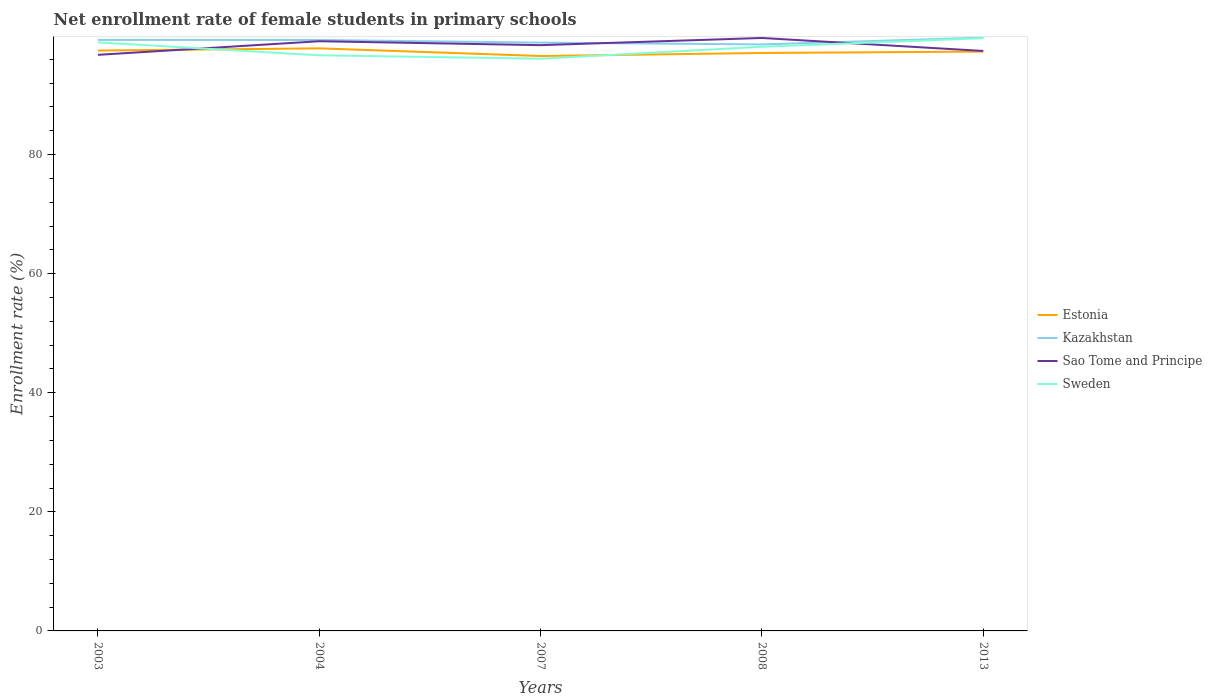Across all years, what is the maximum net enrollment rate of female students in primary schools in Sao Tome and Principe?
Ensure brevity in your answer.  96.75. In which year was the net enrollment rate of female students in primary schools in Sweden maximum?
Ensure brevity in your answer.  2007. What is the total net enrollment rate of female students in primary schools in Sao Tome and Principe in the graph?
Make the answer very short. -0.65. What is the difference between the highest and the second highest net enrollment rate of female students in primary schools in Estonia?
Your answer should be very brief. 1.29. What is the difference between the highest and the lowest net enrollment rate of female students in primary schools in Sao Tome and Principe?
Offer a very short reply. 3. How many lines are there?
Give a very brief answer. 4. Are the values on the major ticks of Y-axis written in scientific E-notation?
Your response must be concise. No. Does the graph contain any zero values?
Give a very brief answer. No. How are the legend labels stacked?
Offer a terse response. Vertical. What is the title of the graph?
Provide a succinct answer. Net enrollment rate of female students in primary schools. What is the label or title of the Y-axis?
Offer a terse response. Enrollment rate (%). What is the Enrollment rate (%) of Estonia in 2003?
Ensure brevity in your answer.  97.47. What is the Enrollment rate (%) of Kazakhstan in 2003?
Keep it short and to the point. 99.25. What is the Enrollment rate (%) in Sao Tome and Principe in 2003?
Your answer should be very brief. 96.75. What is the Enrollment rate (%) of Sweden in 2003?
Your answer should be very brief. 98.83. What is the Enrollment rate (%) in Estonia in 2004?
Provide a short and direct response. 97.83. What is the Enrollment rate (%) in Kazakhstan in 2004?
Make the answer very short. 99.24. What is the Enrollment rate (%) in Sao Tome and Principe in 2004?
Keep it short and to the point. 99.03. What is the Enrollment rate (%) in Sweden in 2004?
Keep it short and to the point. 96.67. What is the Enrollment rate (%) of Estonia in 2007?
Keep it short and to the point. 96.55. What is the Enrollment rate (%) in Kazakhstan in 2007?
Give a very brief answer. 98.8. What is the Enrollment rate (%) of Sao Tome and Principe in 2007?
Give a very brief answer. 98.37. What is the Enrollment rate (%) in Sweden in 2007?
Give a very brief answer. 96.1. What is the Enrollment rate (%) in Estonia in 2008?
Provide a succinct answer. 97.06. What is the Enrollment rate (%) of Kazakhstan in 2008?
Provide a succinct answer. 98.49. What is the Enrollment rate (%) of Sao Tome and Principe in 2008?
Provide a succinct answer. 99.58. What is the Enrollment rate (%) of Sweden in 2008?
Offer a terse response. 98.1. What is the Enrollment rate (%) of Estonia in 2013?
Provide a short and direct response. 97.29. What is the Enrollment rate (%) in Kazakhstan in 2013?
Keep it short and to the point. 99.64. What is the Enrollment rate (%) of Sao Tome and Principe in 2013?
Provide a short and direct response. 97.39. What is the Enrollment rate (%) in Sweden in 2013?
Your answer should be very brief. 99.54. Across all years, what is the maximum Enrollment rate (%) of Estonia?
Your response must be concise. 97.83. Across all years, what is the maximum Enrollment rate (%) in Kazakhstan?
Make the answer very short. 99.64. Across all years, what is the maximum Enrollment rate (%) in Sao Tome and Principe?
Give a very brief answer. 99.58. Across all years, what is the maximum Enrollment rate (%) of Sweden?
Offer a very short reply. 99.54. Across all years, what is the minimum Enrollment rate (%) of Estonia?
Offer a terse response. 96.55. Across all years, what is the minimum Enrollment rate (%) in Kazakhstan?
Your response must be concise. 98.49. Across all years, what is the minimum Enrollment rate (%) in Sao Tome and Principe?
Offer a very short reply. 96.75. Across all years, what is the minimum Enrollment rate (%) of Sweden?
Offer a very short reply. 96.1. What is the total Enrollment rate (%) of Estonia in the graph?
Your answer should be very brief. 486.2. What is the total Enrollment rate (%) of Kazakhstan in the graph?
Ensure brevity in your answer.  495.41. What is the total Enrollment rate (%) of Sao Tome and Principe in the graph?
Your answer should be compact. 491.12. What is the total Enrollment rate (%) in Sweden in the graph?
Keep it short and to the point. 489.24. What is the difference between the Enrollment rate (%) of Estonia in 2003 and that in 2004?
Your response must be concise. -0.37. What is the difference between the Enrollment rate (%) of Kazakhstan in 2003 and that in 2004?
Your answer should be compact. 0.01. What is the difference between the Enrollment rate (%) in Sao Tome and Principe in 2003 and that in 2004?
Keep it short and to the point. -2.28. What is the difference between the Enrollment rate (%) in Sweden in 2003 and that in 2004?
Your response must be concise. 2.16. What is the difference between the Enrollment rate (%) of Estonia in 2003 and that in 2007?
Offer a terse response. 0.92. What is the difference between the Enrollment rate (%) of Kazakhstan in 2003 and that in 2007?
Provide a succinct answer. 0.45. What is the difference between the Enrollment rate (%) in Sao Tome and Principe in 2003 and that in 2007?
Ensure brevity in your answer.  -1.62. What is the difference between the Enrollment rate (%) of Sweden in 2003 and that in 2007?
Provide a succinct answer. 2.73. What is the difference between the Enrollment rate (%) of Estonia in 2003 and that in 2008?
Offer a very short reply. 0.41. What is the difference between the Enrollment rate (%) of Kazakhstan in 2003 and that in 2008?
Keep it short and to the point. 0.76. What is the difference between the Enrollment rate (%) in Sao Tome and Principe in 2003 and that in 2008?
Your answer should be compact. -2.83. What is the difference between the Enrollment rate (%) of Sweden in 2003 and that in 2008?
Provide a short and direct response. 0.73. What is the difference between the Enrollment rate (%) of Estonia in 2003 and that in 2013?
Your answer should be very brief. 0.18. What is the difference between the Enrollment rate (%) in Kazakhstan in 2003 and that in 2013?
Your answer should be very brief. -0.39. What is the difference between the Enrollment rate (%) in Sao Tome and Principe in 2003 and that in 2013?
Give a very brief answer. -0.65. What is the difference between the Enrollment rate (%) in Sweden in 2003 and that in 2013?
Keep it short and to the point. -0.71. What is the difference between the Enrollment rate (%) of Estonia in 2004 and that in 2007?
Offer a terse response. 1.29. What is the difference between the Enrollment rate (%) of Kazakhstan in 2004 and that in 2007?
Offer a very short reply. 0.44. What is the difference between the Enrollment rate (%) in Sao Tome and Principe in 2004 and that in 2007?
Make the answer very short. 0.66. What is the difference between the Enrollment rate (%) of Sweden in 2004 and that in 2007?
Give a very brief answer. 0.57. What is the difference between the Enrollment rate (%) of Estonia in 2004 and that in 2008?
Your response must be concise. 0.77. What is the difference between the Enrollment rate (%) of Kazakhstan in 2004 and that in 2008?
Your answer should be compact. 0.74. What is the difference between the Enrollment rate (%) of Sao Tome and Principe in 2004 and that in 2008?
Make the answer very short. -0.55. What is the difference between the Enrollment rate (%) of Sweden in 2004 and that in 2008?
Ensure brevity in your answer.  -1.44. What is the difference between the Enrollment rate (%) in Estonia in 2004 and that in 2013?
Keep it short and to the point. 0.54. What is the difference between the Enrollment rate (%) in Kazakhstan in 2004 and that in 2013?
Give a very brief answer. -0.4. What is the difference between the Enrollment rate (%) in Sao Tome and Principe in 2004 and that in 2013?
Your answer should be very brief. 1.63. What is the difference between the Enrollment rate (%) of Sweden in 2004 and that in 2013?
Offer a very short reply. -2.87. What is the difference between the Enrollment rate (%) of Estonia in 2007 and that in 2008?
Offer a terse response. -0.51. What is the difference between the Enrollment rate (%) in Kazakhstan in 2007 and that in 2008?
Provide a succinct answer. 0.3. What is the difference between the Enrollment rate (%) in Sao Tome and Principe in 2007 and that in 2008?
Offer a terse response. -1.21. What is the difference between the Enrollment rate (%) in Sweden in 2007 and that in 2008?
Make the answer very short. -2.01. What is the difference between the Enrollment rate (%) of Estonia in 2007 and that in 2013?
Your response must be concise. -0.74. What is the difference between the Enrollment rate (%) in Kazakhstan in 2007 and that in 2013?
Keep it short and to the point. -0.84. What is the difference between the Enrollment rate (%) of Sao Tome and Principe in 2007 and that in 2013?
Ensure brevity in your answer.  0.98. What is the difference between the Enrollment rate (%) in Sweden in 2007 and that in 2013?
Keep it short and to the point. -3.44. What is the difference between the Enrollment rate (%) in Estonia in 2008 and that in 2013?
Provide a short and direct response. -0.23. What is the difference between the Enrollment rate (%) in Kazakhstan in 2008 and that in 2013?
Your answer should be very brief. -1.14. What is the difference between the Enrollment rate (%) in Sao Tome and Principe in 2008 and that in 2013?
Your answer should be very brief. 2.18. What is the difference between the Enrollment rate (%) of Sweden in 2008 and that in 2013?
Give a very brief answer. -1.43. What is the difference between the Enrollment rate (%) of Estonia in 2003 and the Enrollment rate (%) of Kazakhstan in 2004?
Give a very brief answer. -1.77. What is the difference between the Enrollment rate (%) in Estonia in 2003 and the Enrollment rate (%) in Sao Tome and Principe in 2004?
Provide a short and direct response. -1.56. What is the difference between the Enrollment rate (%) of Estonia in 2003 and the Enrollment rate (%) of Sweden in 2004?
Provide a succinct answer. 0.8. What is the difference between the Enrollment rate (%) in Kazakhstan in 2003 and the Enrollment rate (%) in Sao Tome and Principe in 2004?
Ensure brevity in your answer.  0.22. What is the difference between the Enrollment rate (%) of Kazakhstan in 2003 and the Enrollment rate (%) of Sweden in 2004?
Your response must be concise. 2.58. What is the difference between the Enrollment rate (%) of Sao Tome and Principe in 2003 and the Enrollment rate (%) of Sweden in 2004?
Your answer should be compact. 0.08. What is the difference between the Enrollment rate (%) of Estonia in 2003 and the Enrollment rate (%) of Kazakhstan in 2007?
Offer a terse response. -1.33. What is the difference between the Enrollment rate (%) of Estonia in 2003 and the Enrollment rate (%) of Sao Tome and Principe in 2007?
Your answer should be compact. -0.9. What is the difference between the Enrollment rate (%) of Estonia in 2003 and the Enrollment rate (%) of Sweden in 2007?
Offer a terse response. 1.37. What is the difference between the Enrollment rate (%) in Kazakhstan in 2003 and the Enrollment rate (%) in Sao Tome and Principe in 2007?
Your answer should be very brief. 0.88. What is the difference between the Enrollment rate (%) in Kazakhstan in 2003 and the Enrollment rate (%) in Sweden in 2007?
Provide a short and direct response. 3.15. What is the difference between the Enrollment rate (%) of Sao Tome and Principe in 2003 and the Enrollment rate (%) of Sweden in 2007?
Your answer should be very brief. 0.65. What is the difference between the Enrollment rate (%) in Estonia in 2003 and the Enrollment rate (%) in Kazakhstan in 2008?
Provide a succinct answer. -1.03. What is the difference between the Enrollment rate (%) in Estonia in 2003 and the Enrollment rate (%) in Sao Tome and Principe in 2008?
Provide a succinct answer. -2.11. What is the difference between the Enrollment rate (%) of Estonia in 2003 and the Enrollment rate (%) of Sweden in 2008?
Make the answer very short. -0.64. What is the difference between the Enrollment rate (%) of Kazakhstan in 2003 and the Enrollment rate (%) of Sao Tome and Principe in 2008?
Provide a short and direct response. -0.33. What is the difference between the Enrollment rate (%) of Kazakhstan in 2003 and the Enrollment rate (%) of Sweden in 2008?
Offer a terse response. 1.15. What is the difference between the Enrollment rate (%) of Sao Tome and Principe in 2003 and the Enrollment rate (%) of Sweden in 2008?
Offer a terse response. -1.36. What is the difference between the Enrollment rate (%) of Estonia in 2003 and the Enrollment rate (%) of Kazakhstan in 2013?
Provide a short and direct response. -2.17. What is the difference between the Enrollment rate (%) of Estonia in 2003 and the Enrollment rate (%) of Sao Tome and Principe in 2013?
Give a very brief answer. 0.07. What is the difference between the Enrollment rate (%) in Estonia in 2003 and the Enrollment rate (%) in Sweden in 2013?
Your answer should be compact. -2.07. What is the difference between the Enrollment rate (%) of Kazakhstan in 2003 and the Enrollment rate (%) of Sao Tome and Principe in 2013?
Offer a very short reply. 1.85. What is the difference between the Enrollment rate (%) in Kazakhstan in 2003 and the Enrollment rate (%) in Sweden in 2013?
Give a very brief answer. -0.29. What is the difference between the Enrollment rate (%) in Sao Tome and Principe in 2003 and the Enrollment rate (%) in Sweden in 2013?
Provide a short and direct response. -2.79. What is the difference between the Enrollment rate (%) in Estonia in 2004 and the Enrollment rate (%) in Kazakhstan in 2007?
Give a very brief answer. -0.96. What is the difference between the Enrollment rate (%) of Estonia in 2004 and the Enrollment rate (%) of Sao Tome and Principe in 2007?
Your answer should be very brief. -0.54. What is the difference between the Enrollment rate (%) in Estonia in 2004 and the Enrollment rate (%) in Sweden in 2007?
Make the answer very short. 1.74. What is the difference between the Enrollment rate (%) in Kazakhstan in 2004 and the Enrollment rate (%) in Sao Tome and Principe in 2007?
Provide a short and direct response. 0.87. What is the difference between the Enrollment rate (%) in Kazakhstan in 2004 and the Enrollment rate (%) in Sweden in 2007?
Your response must be concise. 3.14. What is the difference between the Enrollment rate (%) of Sao Tome and Principe in 2004 and the Enrollment rate (%) of Sweden in 2007?
Your answer should be very brief. 2.93. What is the difference between the Enrollment rate (%) in Estonia in 2004 and the Enrollment rate (%) in Kazakhstan in 2008?
Offer a terse response. -0.66. What is the difference between the Enrollment rate (%) of Estonia in 2004 and the Enrollment rate (%) of Sao Tome and Principe in 2008?
Provide a succinct answer. -1.74. What is the difference between the Enrollment rate (%) in Estonia in 2004 and the Enrollment rate (%) in Sweden in 2008?
Make the answer very short. -0.27. What is the difference between the Enrollment rate (%) of Kazakhstan in 2004 and the Enrollment rate (%) of Sao Tome and Principe in 2008?
Make the answer very short. -0.34. What is the difference between the Enrollment rate (%) of Kazakhstan in 2004 and the Enrollment rate (%) of Sweden in 2008?
Make the answer very short. 1.13. What is the difference between the Enrollment rate (%) in Sao Tome and Principe in 2004 and the Enrollment rate (%) in Sweden in 2008?
Provide a short and direct response. 0.92. What is the difference between the Enrollment rate (%) in Estonia in 2004 and the Enrollment rate (%) in Kazakhstan in 2013?
Ensure brevity in your answer.  -1.8. What is the difference between the Enrollment rate (%) of Estonia in 2004 and the Enrollment rate (%) of Sao Tome and Principe in 2013?
Your response must be concise. 0.44. What is the difference between the Enrollment rate (%) of Estonia in 2004 and the Enrollment rate (%) of Sweden in 2013?
Make the answer very short. -1.71. What is the difference between the Enrollment rate (%) in Kazakhstan in 2004 and the Enrollment rate (%) in Sao Tome and Principe in 2013?
Your answer should be compact. 1.84. What is the difference between the Enrollment rate (%) in Kazakhstan in 2004 and the Enrollment rate (%) in Sweden in 2013?
Provide a short and direct response. -0.3. What is the difference between the Enrollment rate (%) in Sao Tome and Principe in 2004 and the Enrollment rate (%) in Sweden in 2013?
Your answer should be compact. -0.51. What is the difference between the Enrollment rate (%) in Estonia in 2007 and the Enrollment rate (%) in Kazakhstan in 2008?
Keep it short and to the point. -1.95. What is the difference between the Enrollment rate (%) of Estonia in 2007 and the Enrollment rate (%) of Sao Tome and Principe in 2008?
Keep it short and to the point. -3.03. What is the difference between the Enrollment rate (%) in Estonia in 2007 and the Enrollment rate (%) in Sweden in 2008?
Make the answer very short. -1.56. What is the difference between the Enrollment rate (%) of Kazakhstan in 2007 and the Enrollment rate (%) of Sao Tome and Principe in 2008?
Provide a short and direct response. -0.78. What is the difference between the Enrollment rate (%) in Kazakhstan in 2007 and the Enrollment rate (%) in Sweden in 2008?
Ensure brevity in your answer.  0.69. What is the difference between the Enrollment rate (%) of Sao Tome and Principe in 2007 and the Enrollment rate (%) of Sweden in 2008?
Keep it short and to the point. 0.27. What is the difference between the Enrollment rate (%) in Estonia in 2007 and the Enrollment rate (%) in Kazakhstan in 2013?
Give a very brief answer. -3.09. What is the difference between the Enrollment rate (%) in Estonia in 2007 and the Enrollment rate (%) in Sao Tome and Principe in 2013?
Keep it short and to the point. -0.85. What is the difference between the Enrollment rate (%) in Estonia in 2007 and the Enrollment rate (%) in Sweden in 2013?
Your response must be concise. -2.99. What is the difference between the Enrollment rate (%) in Kazakhstan in 2007 and the Enrollment rate (%) in Sao Tome and Principe in 2013?
Offer a very short reply. 1.4. What is the difference between the Enrollment rate (%) of Kazakhstan in 2007 and the Enrollment rate (%) of Sweden in 2013?
Your answer should be compact. -0.74. What is the difference between the Enrollment rate (%) of Sao Tome and Principe in 2007 and the Enrollment rate (%) of Sweden in 2013?
Offer a very short reply. -1.17. What is the difference between the Enrollment rate (%) in Estonia in 2008 and the Enrollment rate (%) in Kazakhstan in 2013?
Make the answer very short. -2.58. What is the difference between the Enrollment rate (%) in Estonia in 2008 and the Enrollment rate (%) in Sao Tome and Principe in 2013?
Your answer should be compact. -0.34. What is the difference between the Enrollment rate (%) in Estonia in 2008 and the Enrollment rate (%) in Sweden in 2013?
Ensure brevity in your answer.  -2.48. What is the difference between the Enrollment rate (%) in Kazakhstan in 2008 and the Enrollment rate (%) in Sao Tome and Principe in 2013?
Keep it short and to the point. 1.1. What is the difference between the Enrollment rate (%) of Kazakhstan in 2008 and the Enrollment rate (%) of Sweden in 2013?
Keep it short and to the point. -1.04. What is the difference between the Enrollment rate (%) of Sao Tome and Principe in 2008 and the Enrollment rate (%) of Sweden in 2013?
Your answer should be very brief. 0.04. What is the average Enrollment rate (%) in Estonia per year?
Provide a short and direct response. 97.24. What is the average Enrollment rate (%) of Kazakhstan per year?
Your answer should be compact. 99.08. What is the average Enrollment rate (%) in Sao Tome and Principe per year?
Make the answer very short. 98.22. What is the average Enrollment rate (%) of Sweden per year?
Provide a short and direct response. 97.85. In the year 2003, what is the difference between the Enrollment rate (%) of Estonia and Enrollment rate (%) of Kazakhstan?
Offer a terse response. -1.78. In the year 2003, what is the difference between the Enrollment rate (%) in Estonia and Enrollment rate (%) in Sao Tome and Principe?
Give a very brief answer. 0.72. In the year 2003, what is the difference between the Enrollment rate (%) of Estonia and Enrollment rate (%) of Sweden?
Keep it short and to the point. -1.37. In the year 2003, what is the difference between the Enrollment rate (%) of Kazakhstan and Enrollment rate (%) of Sao Tome and Principe?
Your answer should be very brief. 2.5. In the year 2003, what is the difference between the Enrollment rate (%) of Kazakhstan and Enrollment rate (%) of Sweden?
Your answer should be compact. 0.42. In the year 2003, what is the difference between the Enrollment rate (%) of Sao Tome and Principe and Enrollment rate (%) of Sweden?
Offer a very short reply. -2.09. In the year 2004, what is the difference between the Enrollment rate (%) of Estonia and Enrollment rate (%) of Kazakhstan?
Give a very brief answer. -1.4. In the year 2004, what is the difference between the Enrollment rate (%) of Estonia and Enrollment rate (%) of Sao Tome and Principe?
Provide a short and direct response. -1.19. In the year 2004, what is the difference between the Enrollment rate (%) in Estonia and Enrollment rate (%) in Sweden?
Offer a very short reply. 1.17. In the year 2004, what is the difference between the Enrollment rate (%) of Kazakhstan and Enrollment rate (%) of Sao Tome and Principe?
Offer a terse response. 0.21. In the year 2004, what is the difference between the Enrollment rate (%) in Kazakhstan and Enrollment rate (%) in Sweden?
Provide a succinct answer. 2.57. In the year 2004, what is the difference between the Enrollment rate (%) of Sao Tome and Principe and Enrollment rate (%) of Sweden?
Keep it short and to the point. 2.36. In the year 2007, what is the difference between the Enrollment rate (%) of Estonia and Enrollment rate (%) of Kazakhstan?
Ensure brevity in your answer.  -2.25. In the year 2007, what is the difference between the Enrollment rate (%) of Estonia and Enrollment rate (%) of Sao Tome and Principe?
Your answer should be very brief. -1.82. In the year 2007, what is the difference between the Enrollment rate (%) of Estonia and Enrollment rate (%) of Sweden?
Offer a terse response. 0.45. In the year 2007, what is the difference between the Enrollment rate (%) in Kazakhstan and Enrollment rate (%) in Sao Tome and Principe?
Offer a terse response. 0.43. In the year 2007, what is the difference between the Enrollment rate (%) in Kazakhstan and Enrollment rate (%) in Sweden?
Your response must be concise. 2.7. In the year 2007, what is the difference between the Enrollment rate (%) in Sao Tome and Principe and Enrollment rate (%) in Sweden?
Your response must be concise. 2.27. In the year 2008, what is the difference between the Enrollment rate (%) of Estonia and Enrollment rate (%) of Kazakhstan?
Keep it short and to the point. -1.44. In the year 2008, what is the difference between the Enrollment rate (%) in Estonia and Enrollment rate (%) in Sao Tome and Principe?
Offer a terse response. -2.52. In the year 2008, what is the difference between the Enrollment rate (%) of Estonia and Enrollment rate (%) of Sweden?
Provide a short and direct response. -1.05. In the year 2008, what is the difference between the Enrollment rate (%) in Kazakhstan and Enrollment rate (%) in Sao Tome and Principe?
Provide a succinct answer. -1.08. In the year 2008, what is the difference between the Enrollment rate (%) in Kazakhstan and Enrollment rate (%) in Sweden?
Your answer should be very brief. 0.39. In the year 2008, what is the difference between the Enrollment rate (%) in Sao Tome and Principe and Enrollment rate (%) in Sweden?
Make the answer very short. 1.47. In the year 2013, what is the difference between the Enrollment rate (%) of Estonia and Enrollment rate (%) of Kazakhstan?
Make the answer very short. -2.34. In the year 2013, what is the difference between the Enrollment rate (%) of Estonia and Enrollment rate (%) of Sao Tome and Principe?
Offer a very short reply. -0.1. In the year 2013, what is the difference between the Enrollment rate (%) in Estonia and Enrollment rate (%) in Sweden?
Your answer should be very brief. -2.25. In the year 2013, what is the difference between the Enrollment rate (%) in Kazakhstan and Enrollment rate (%) in Sao Tome and Principe?
Ensure brevity in your answer.  2.24. In the year 2013, what is the difference between the Enrollment rate (%) of Kazakhstan and Enrollment rate (%) of Sweden?
Make the answer very short. 0.1. In the year 2013, what is the difference between the Enrollment rate (%) in Sao Tome and Principe and Enrollment rate (%) in Sweden?
Make the answer very short. -2.14. What is the ratio of the Enrollment rate (%) in Estonia in 2003 to that in 2004?
Offer a terse response. 1. What is the ratio of the Enrollment rate (%) in Sao Tome and Principe in 2003 to that in 2004?
Your answer should be compact. 0.98. What is the ratio of the Enrollment rate (%) in Sweden in 2003 to that in 2004?
Give a very brief answer. 1.02. What is the ratio of the Enrollment rate (%) of Estonia in 2003 to that in 2007?
Provide a short and direct response. 1.01. What is the ratio of the Enrollment rate (%) of Sao Tome and Principe in 2003 to that in 2007?
Provide a succinct answer. 0.98. What is the ratio of the Enrollment rate (%) in Sweden in 2003 to that in 2007?
Make the answer very short. 1.03. What is the ratio of the Enrollment rate (%) of Kazakhstan in 2003 to that in 2008?
Your answer should be compact. 1.01. What is the ratio of the Enrollment rate (%) of Sao Tome and Principe in 2003 to that in 2008?
Provide a succinct answer. 0.97. What is the ratio of the Enrollment rate (%) in Sweden in 2003 to that in 2008?
Keep it short and to the point. 1.01. What is the ratio of the Enrollment rate (%) of Kazakhstan in 2003 to that in 2013?
Make the answer very short. 1. What is the ratio of the Enrollment rate (%) of Estonia in 2004 to that in 2007?
Offer a terse response. 1.01. What is the ratio of the Enrollment rate (%) of Sweden in 2004 to that in 2007?
Offer a terse response. 1.01. What is the ratio of the Enrollment rate (%) of Kazakhstan in 2004 to that in 2008?
Provide a short and direct response. 1.01. What is the ratio of the Enrollment rate (%) in Sweden in 2004 to that in 2008?
Make the answer very short. 0.99. What is the ratio of the Enrollment rate (%) of Estonia in 2004 to that in 2013?
Give a very brief answer. 1.01. What is the ratio of the Enrollment rate (%) of Kazakhstan in 2004 to that in 2013?
Your answer should be compact. 1. What is the ratio of the Enrollment rate (%) of Sao Tome and Principe in 2004 to that in 2013?
Provide a short and direct response. 1.02. What is the ratio of the Enrollment rate (%) of Sweden in 2004 to that in 2013?
Provide a short and direct response. 0.97. What is the ratio of the Enrollment rate (%) in Kazakhstan in 2007 to that in 2008?
Your answer should be compact. 1. What is the ratio of the Enrollment rate (%) in Sao Tome and Principe in 2007 to that in 2008?
Offer a terse response. 0.99. What is the ratio of the Enrollment rate (%) of Sweden in 2007 to that in 2008?
Offer a terse response. 0.98. What is the ratio of the Enrollment rate (%) of Estonia in 2007 to that in 2013?
Offer a very short reply. 0.99. What is the ratio of the Enrollment rate (%) of Sweden in 2007 to that in 2013?
Make the answer very short. 0.97. What is the ratio of the Enrollment rate (%) in Kazakhstan in 2008 to that in 2013?
Keep it short and to the point. 0.99. What is the ratio of the Enrollment rate (%) in Sao Tome and Principe in 2008 to that in 2013?
Provide a succinct answer. 1.02. What is the ratio of the Enrollment rate (%) of Sweden in 2008 to that in 2013?
Your answer should be very brief. 0.99. What is the difference between the highest and the second highest Enrollment rate (%) of Estonia?
Your response must be concise. 0.37. What is the difference between the highest and the second highest Enrollment rate (%) of Kazakhstan?
Your answer should be compact. 0.39. What is the difference between the highest and the second highest Enrollment rate (%) in Sao Tome and Principe?
Ensure brevity in your answer.  0.55. What is the difference between the highest and the second highest Enrollment rate (%) of Sweden?
Offer a very short reply. 0.71. What is the difference between the highest and the lowest Enrollment rate (%) in Estonia?
Ensure brevity in your answer.  1.29. What is the difference between the highest and the lowest Enrollment rate (%) of Kazakhstan?
Ensure brevity in your answer.  1.14. What is the difference between the highest and the lowest Enrollment rate (%) of Sao Tome and Principe?
Your answer should be very brief. 2.83. What is the difference between the highest and the lowest Enrollment rate (%) of Sweden?
Your response must be concise. 3.44. 